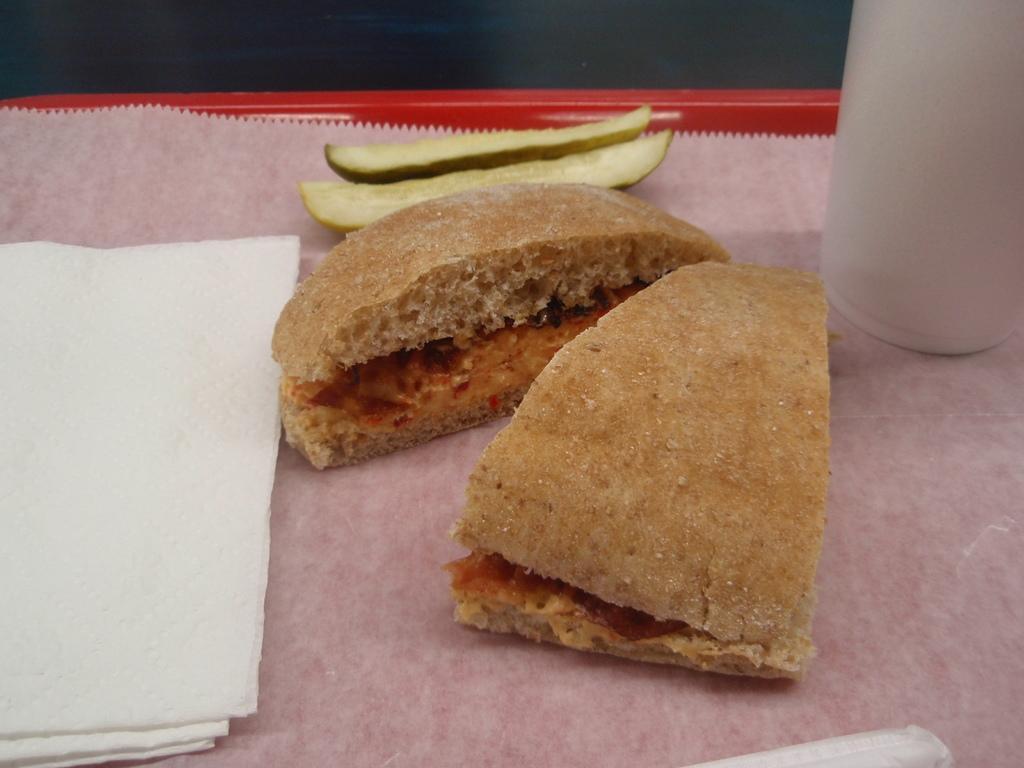In one or two sentences, can you explain what this image depicts? In this image we can see a tray in which a food item, tissues and a glass are there. 